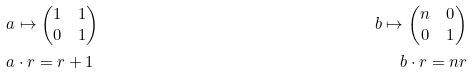Convert formula to latex. <formula><loc_0><loc_0><loc_500><loc_500>& a \mapsto \begin{pmatrix} 1 & 1 \\ 0 & 1 \end{pmatrix} & b \mapsto \begin{pmatrix} n & 0 \\ 0 & 1 \end{pmatrix} \\ & a \cdot r = r + 1 & b \cdot r = n r</formula> 